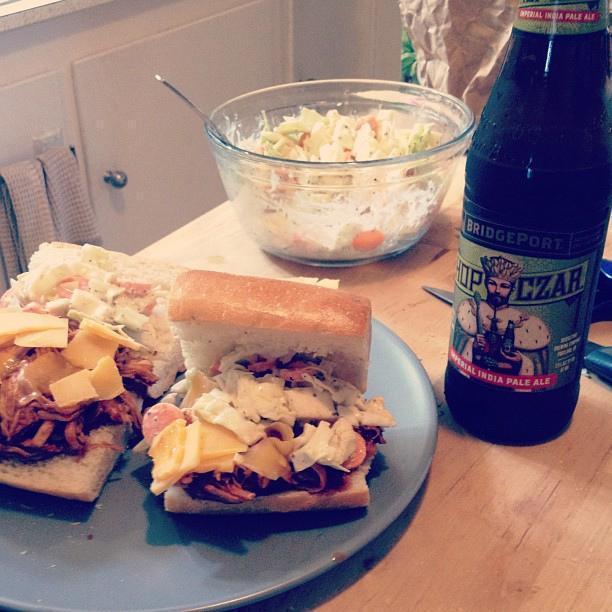Where was this food made?
Select the correct answer and articulate reasoning with the following format: 'Answer: answer
Rationale: rationale.'
Options: Home, store, restaurant, outside. Answer: home.
Rationale: A plate of food is on a casual style plate and a residential countertop. 